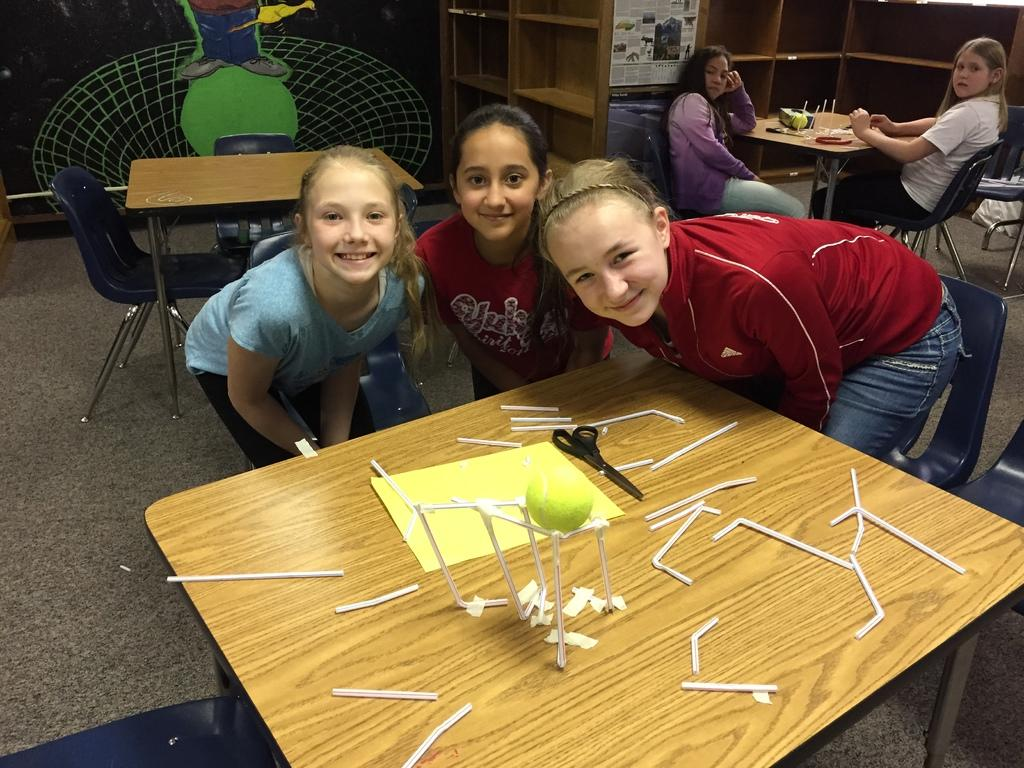How many girls are present in the image? There are 3 girls standing and 2 girls sitting, making a total of 5 girls in the image. What are the girls doing in the image? Some girls are standing, while others are sitting on chairs. What can be seen in the background of the image? There is a wall, a wooden shelf, empty chairs, and a table in the background of the image. Did the earthquake cause the ground to shake in the image? There is no mention of an earthquake or any ground shaking in the image. The image only shows girls standing or sitting and various objects in the background. 